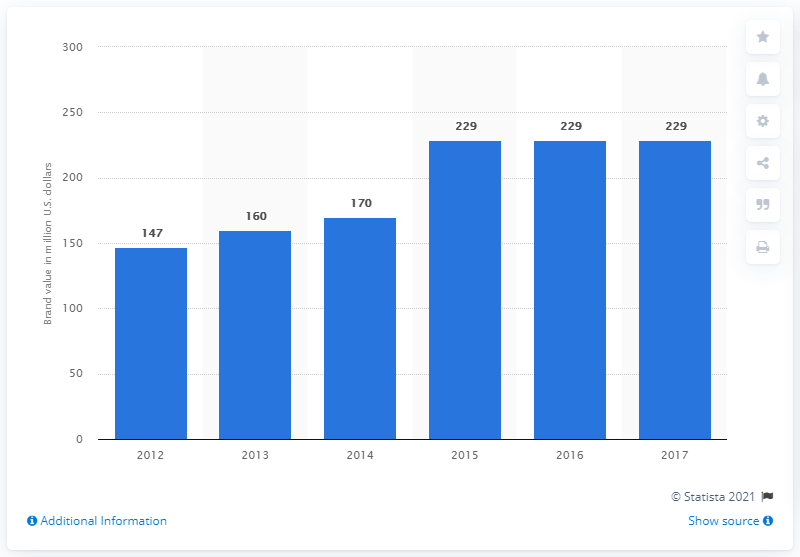Indicate a few pertinent items in this graphic. The brand value of the FIFA World Cup in 2017 was estimated to be $229 billion. 